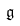Convert formula to latex. <formula><loc_0><loc_0><loc_500><loc_500>\mathfrak { g }</formula> 